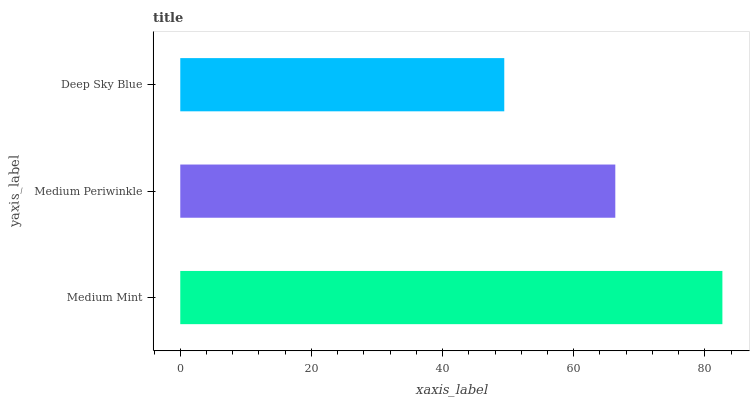Is Deep Sky Blue the minimum?
Answer yes or no. Yes. Is Medium Mint the maximum?
Answer yes or no. Yes. Is Medium Periwinkle the minimum?
Answer yes or no. No. Is Medium Periwinkle the maximum?
Answer yes or no. No. Is Medium Mint greater than Medium Periwinkle?
Answer yes or no. Yes. Is Medium Periwinkle less than Medium Mint?
Answer yes or no. Yes. Is Medium Periwinkle greater than Medium Mint?
Answer yes or no. No. Is Medium Mint less than Medium Periwinkle?
Answer yes or no. No. Is Medium Periwinkle the high median?
Answer yes or no. Yes. Is Medium Periwinkle the low median?
Answer yes or no. Yes. Is Medium Mint the high median?
Answer yes or no. No. Is Medium Mint the low median?
Answer yes or no. No. 